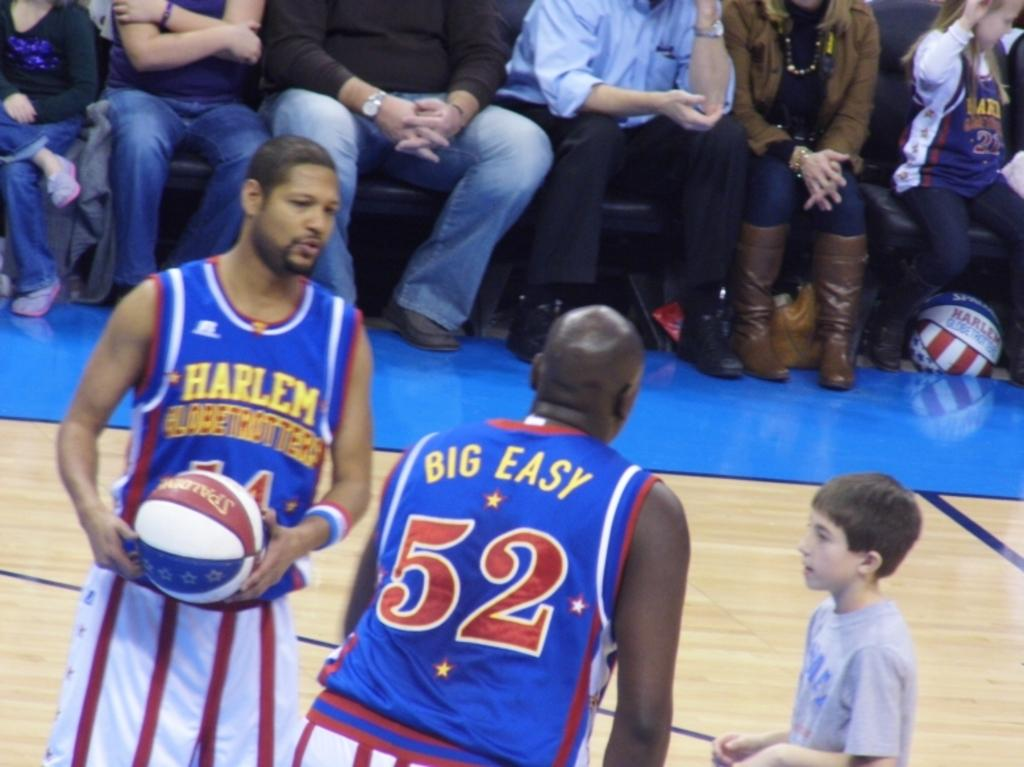<image>
Summarize the visual content of the image. Player number 52 has the words "Big Easy" on the back of his jersey. 